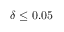Convert formula to latex. <formula><loc_0><loc_0><loc_500><loc_500>\delta \leq 0 . 0 5</formula> 